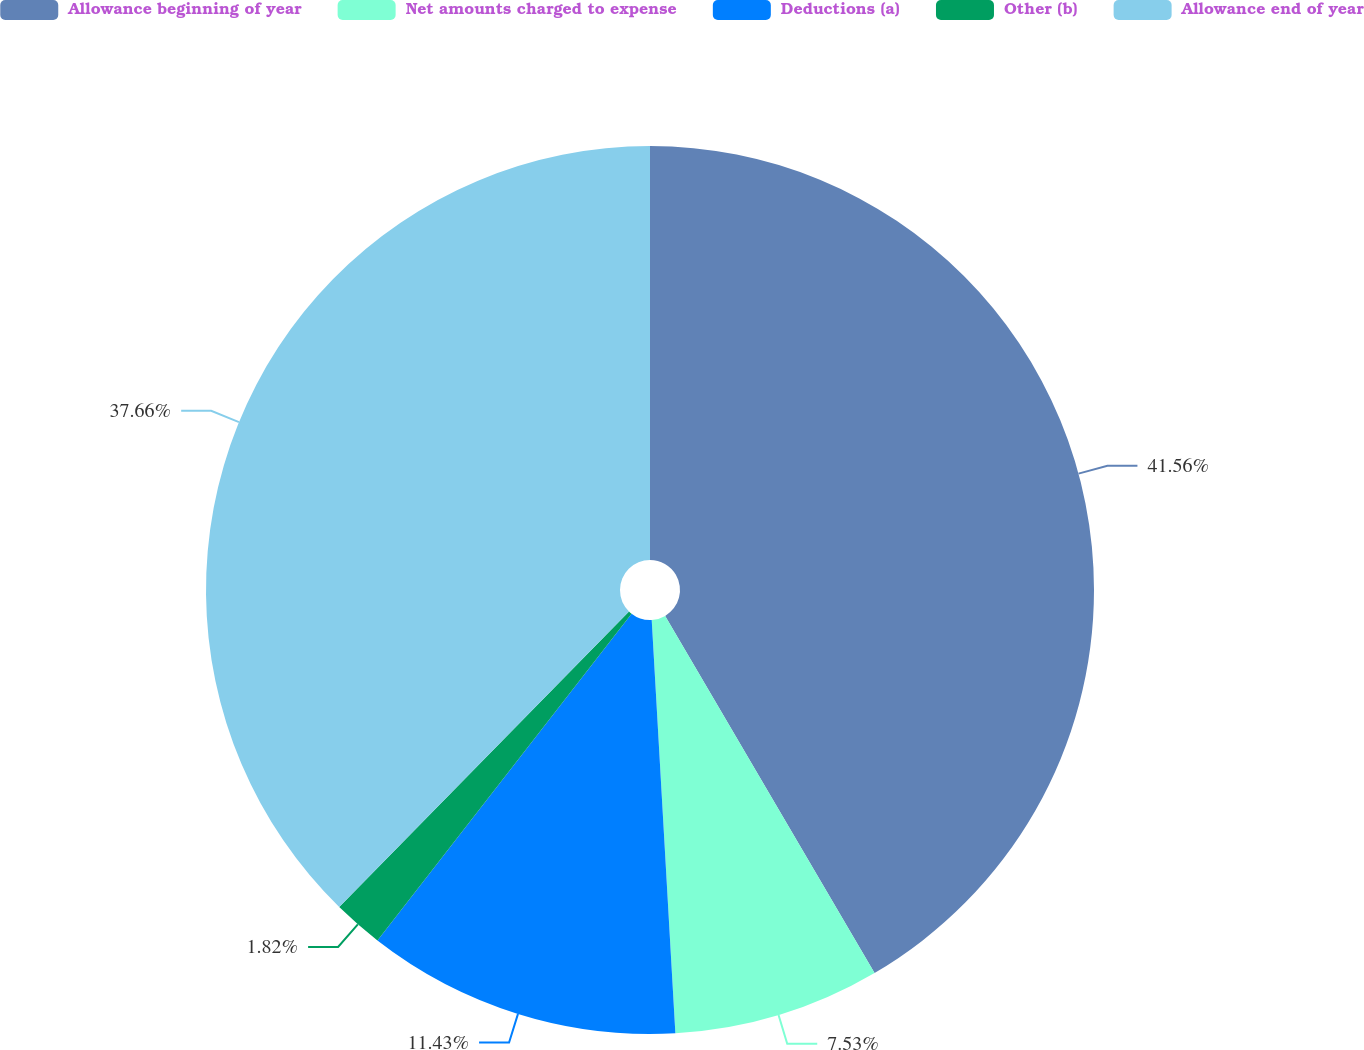Convert chart to OTSL. <chart><loc_0><loc_0><loc_500><loc_500><pie_chart><fcel>Allowance beginning of year<fcel>Net amounts charged to expense<fcel>Deductions (a)<fcel>Other (b)<fcel>Allowance end of year<nl><fcel>41.56%<fcel>7.53%<fcel>11.43%<fcel>1.82%<fcel>37.66%<nl></chart> 